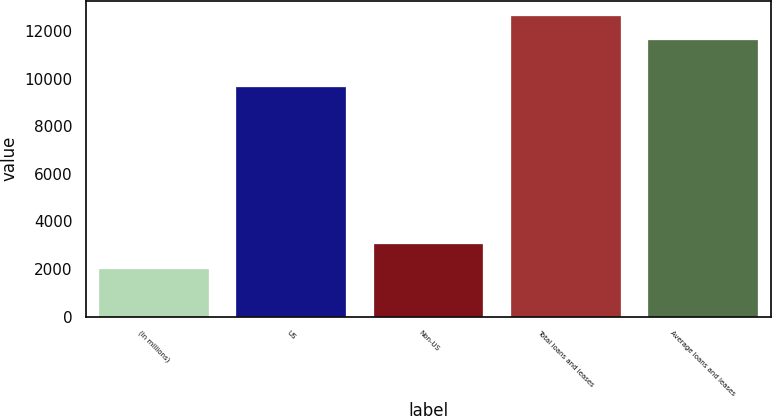Convert chart. <chart><loc_0><loc_0><loc_500><loc_500><bar_chart><fcel>(In millions)<fcel>US<fcel>Non-US<fcel>Total loans and leases<fcel>Average loans and leases<nl><fcel>2012<fcel>9645<fcel>3041.5<fcel>12639.5<fcel>11610<nl></chart> 